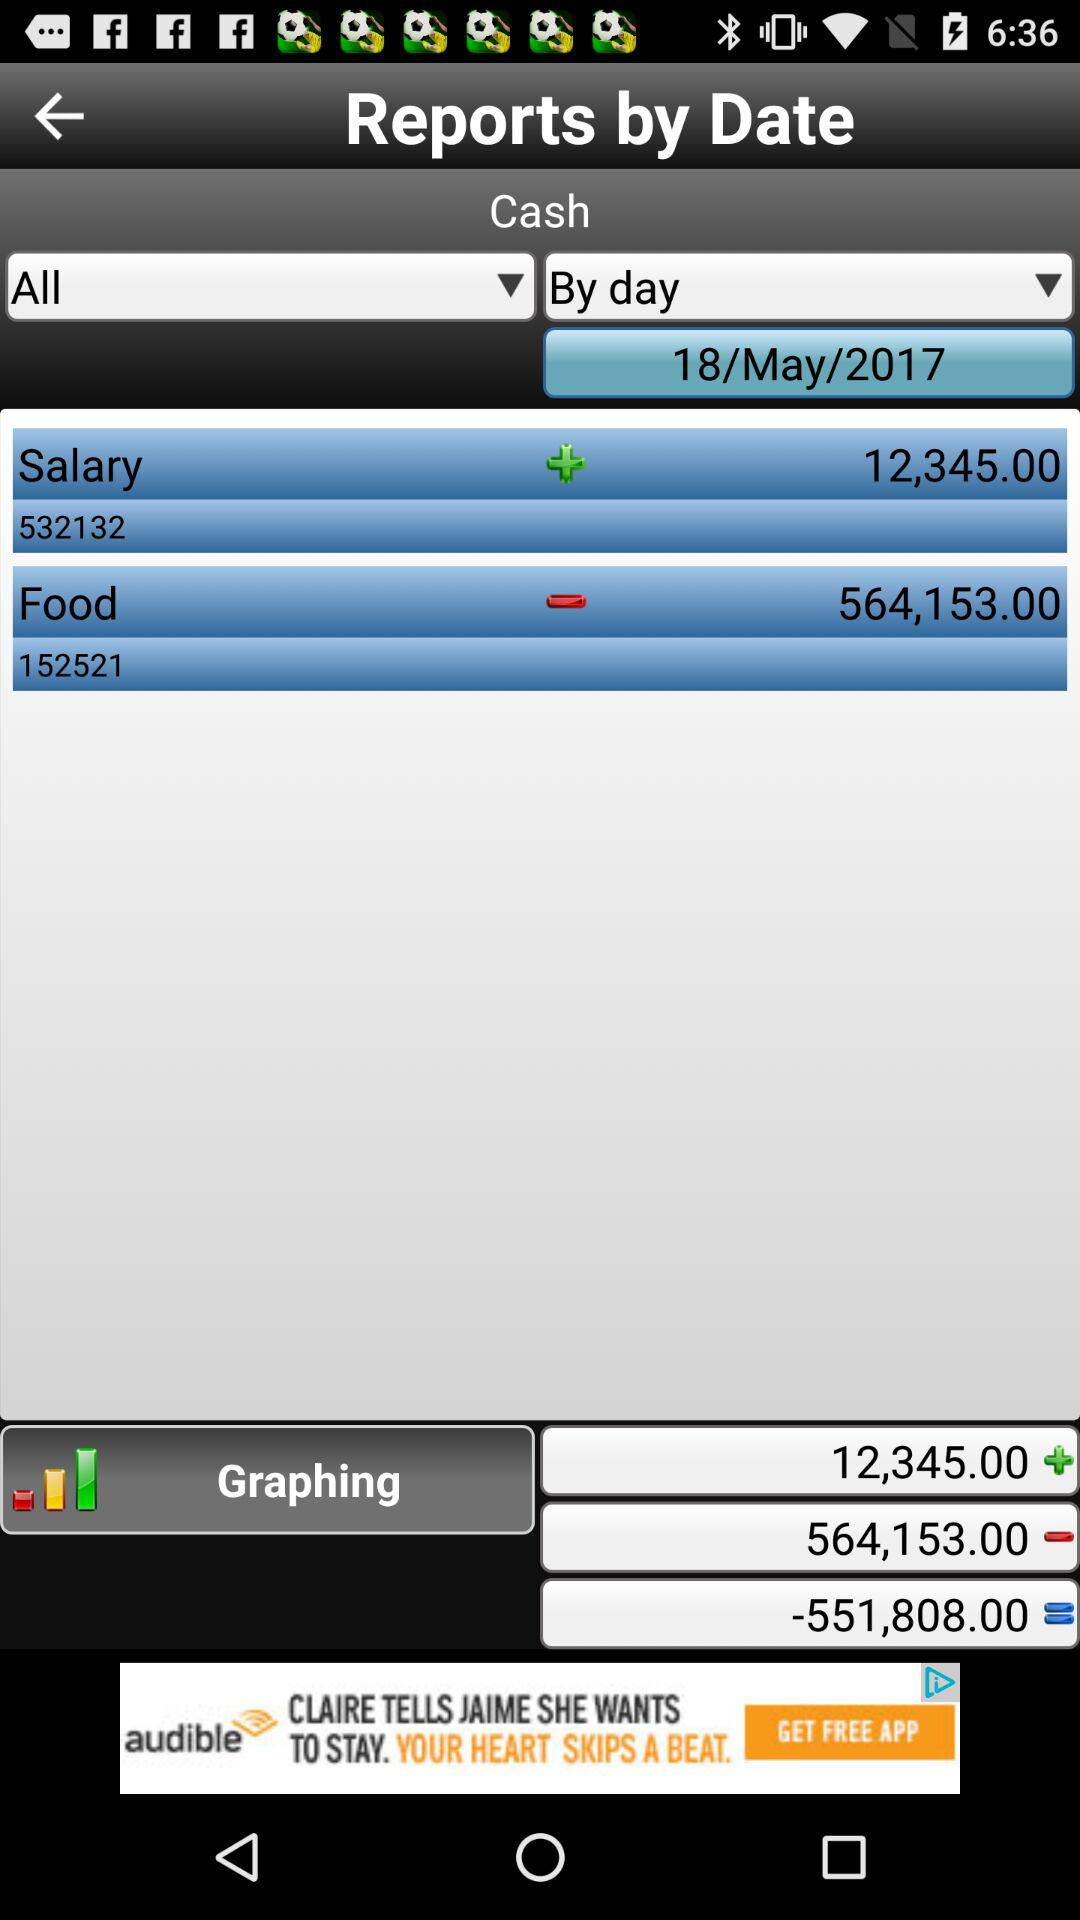What item has a value of 564,153.00? The item is "Food". 